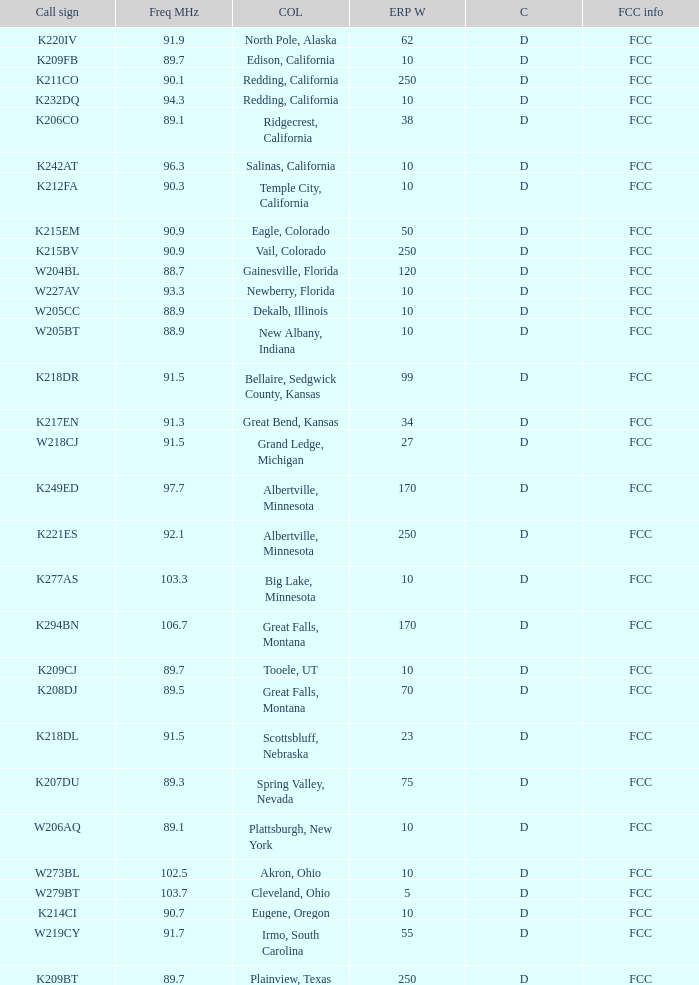What is the call sign of the translator in Spring Valley, Nevada? K207DU. 